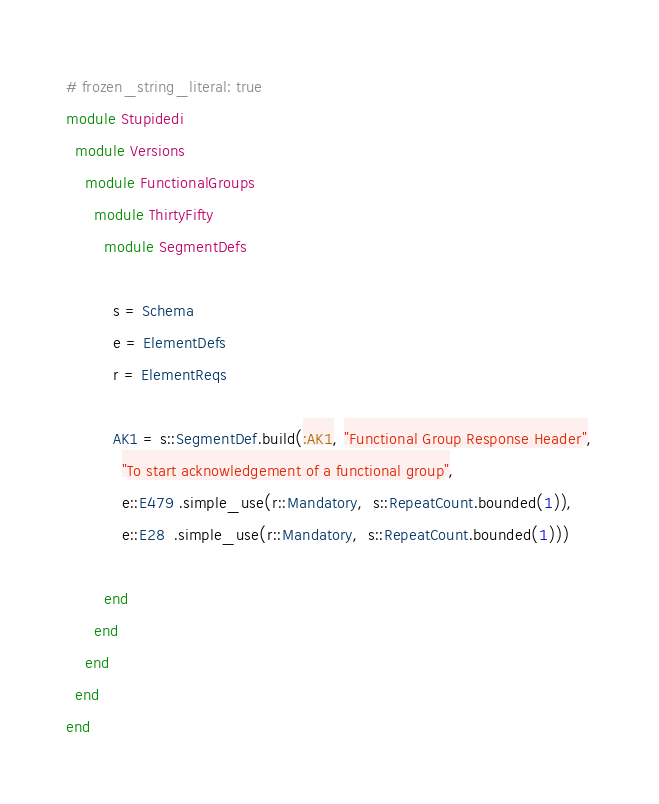Convert code to text. <code><loc_0><loc_0><loc_500><loc_500><_Ruby_># frozen_string_literal: true
module Stupidedi
  module Versions
    module FunctionalGroups
      module ThirtyFifty
        module SegmentDefs

          s = Schema
          e = ElementDefs
          r = ElementReqs

          AK1 = s::SegmentDef.build(:AK1, "Functional Group Response Header",
            "To start acknowledgement of a functional group",
            e::E479 .simple_use(r::Mandatory,  s::RepeatCount.bounded(1)),
            e::E28  .simple_use(r::Mandatory,  s::RepeatCount.bounded(1)))

        end
      end
    end
  end
end
</code> 